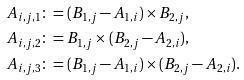<formula> <loc_0><loc_0><loc_500><loc_500>A _ { i , j , 1 } \colon & = ( B _ { 1 , j } - A _ { 1 , i } ) \times B _ { 2 , j } , \\ A _ { i , j , 2 } \colon & = B _ { 1 , j } \times ( B _ { 2 , j } - A _ { 2 , i } ) , \\ A _ { i , j , 3 } \colon & = ( B _ { 1 , j } - A _ { 1 , i } ) \times ( B _ { 2 , j } - A _ { 2 , i } ) .</formula> 